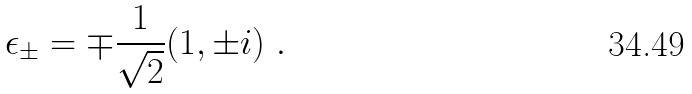Convert formula to latex. <formula><loc_0><loc_0><loc_500><loc_500>\epsilon _ { \pm } = \mp \frac { 1 } { \sqrt { 2 } } ( 1 , \pm i ) \ .</formula> 